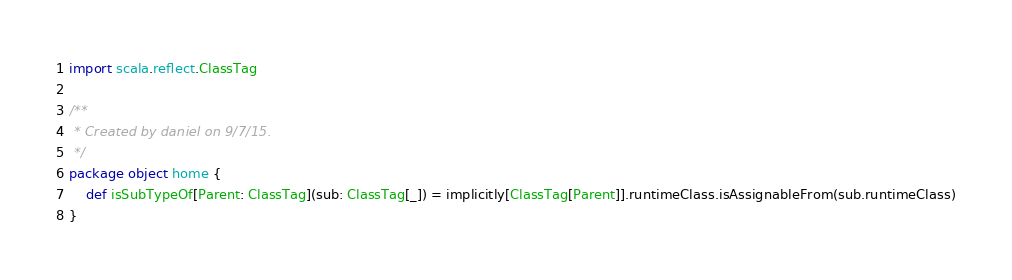Convert code to text. <code><loc_0><loc_0><loc_500><loc_500><_Scala_>import scala.reflect.ClassTag

/**
 * Created by daniel on 9/7/15.
 */
package object home {
    def isSubTypeOf[Parent: ClassTag](sub: ClassTag[_]) = implicitly[ClassTag[Parent]].runtimeClass.isAssignableFrom(sub.runtimeClass)
}
</code> 